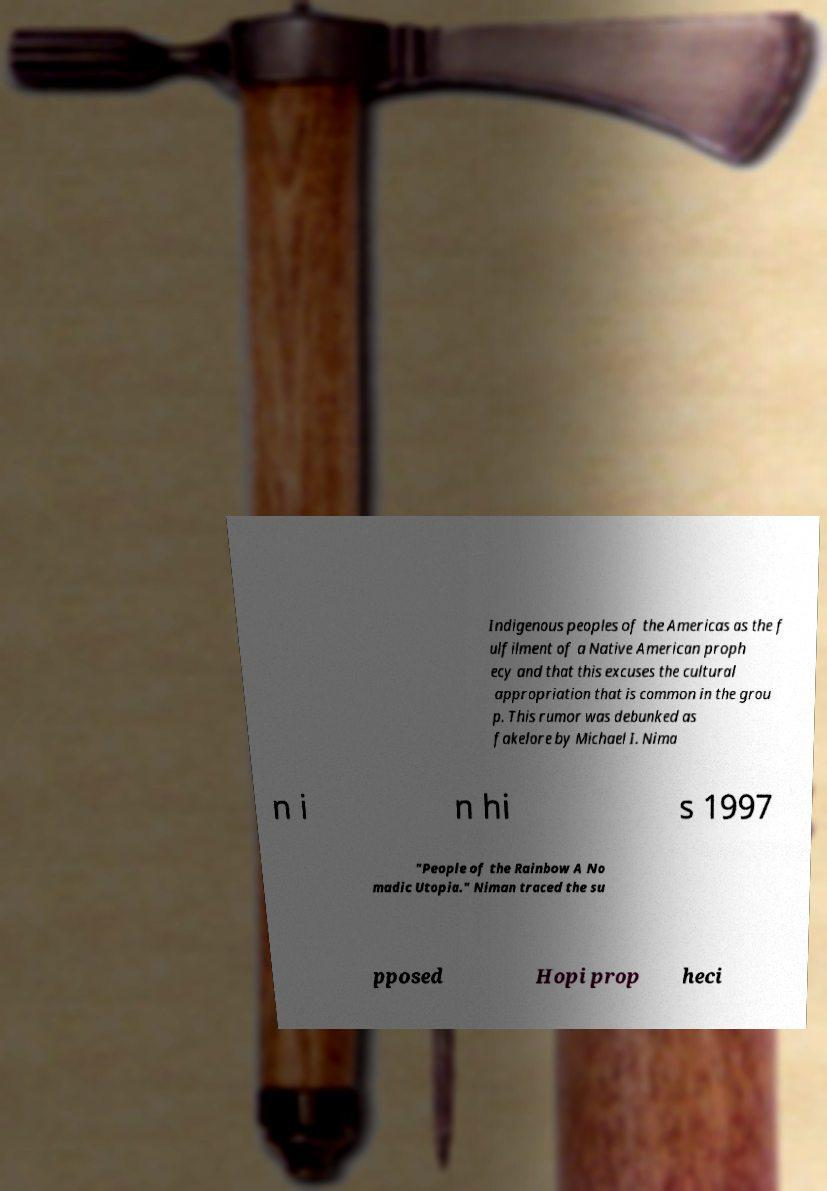Please identify and transcribe the text found in this image. Indigenous peoples of the Americas as the f ulfilment of a Native American proph ecy and that this excuses the cultural appropriation that is common in the grou p. This rumor was debunked as fakelore by Michael I. Nima n i n hi s 1997 "People of the Rainbow A No madic Utopia." Niman traced the su pposed Hopi prop heci 